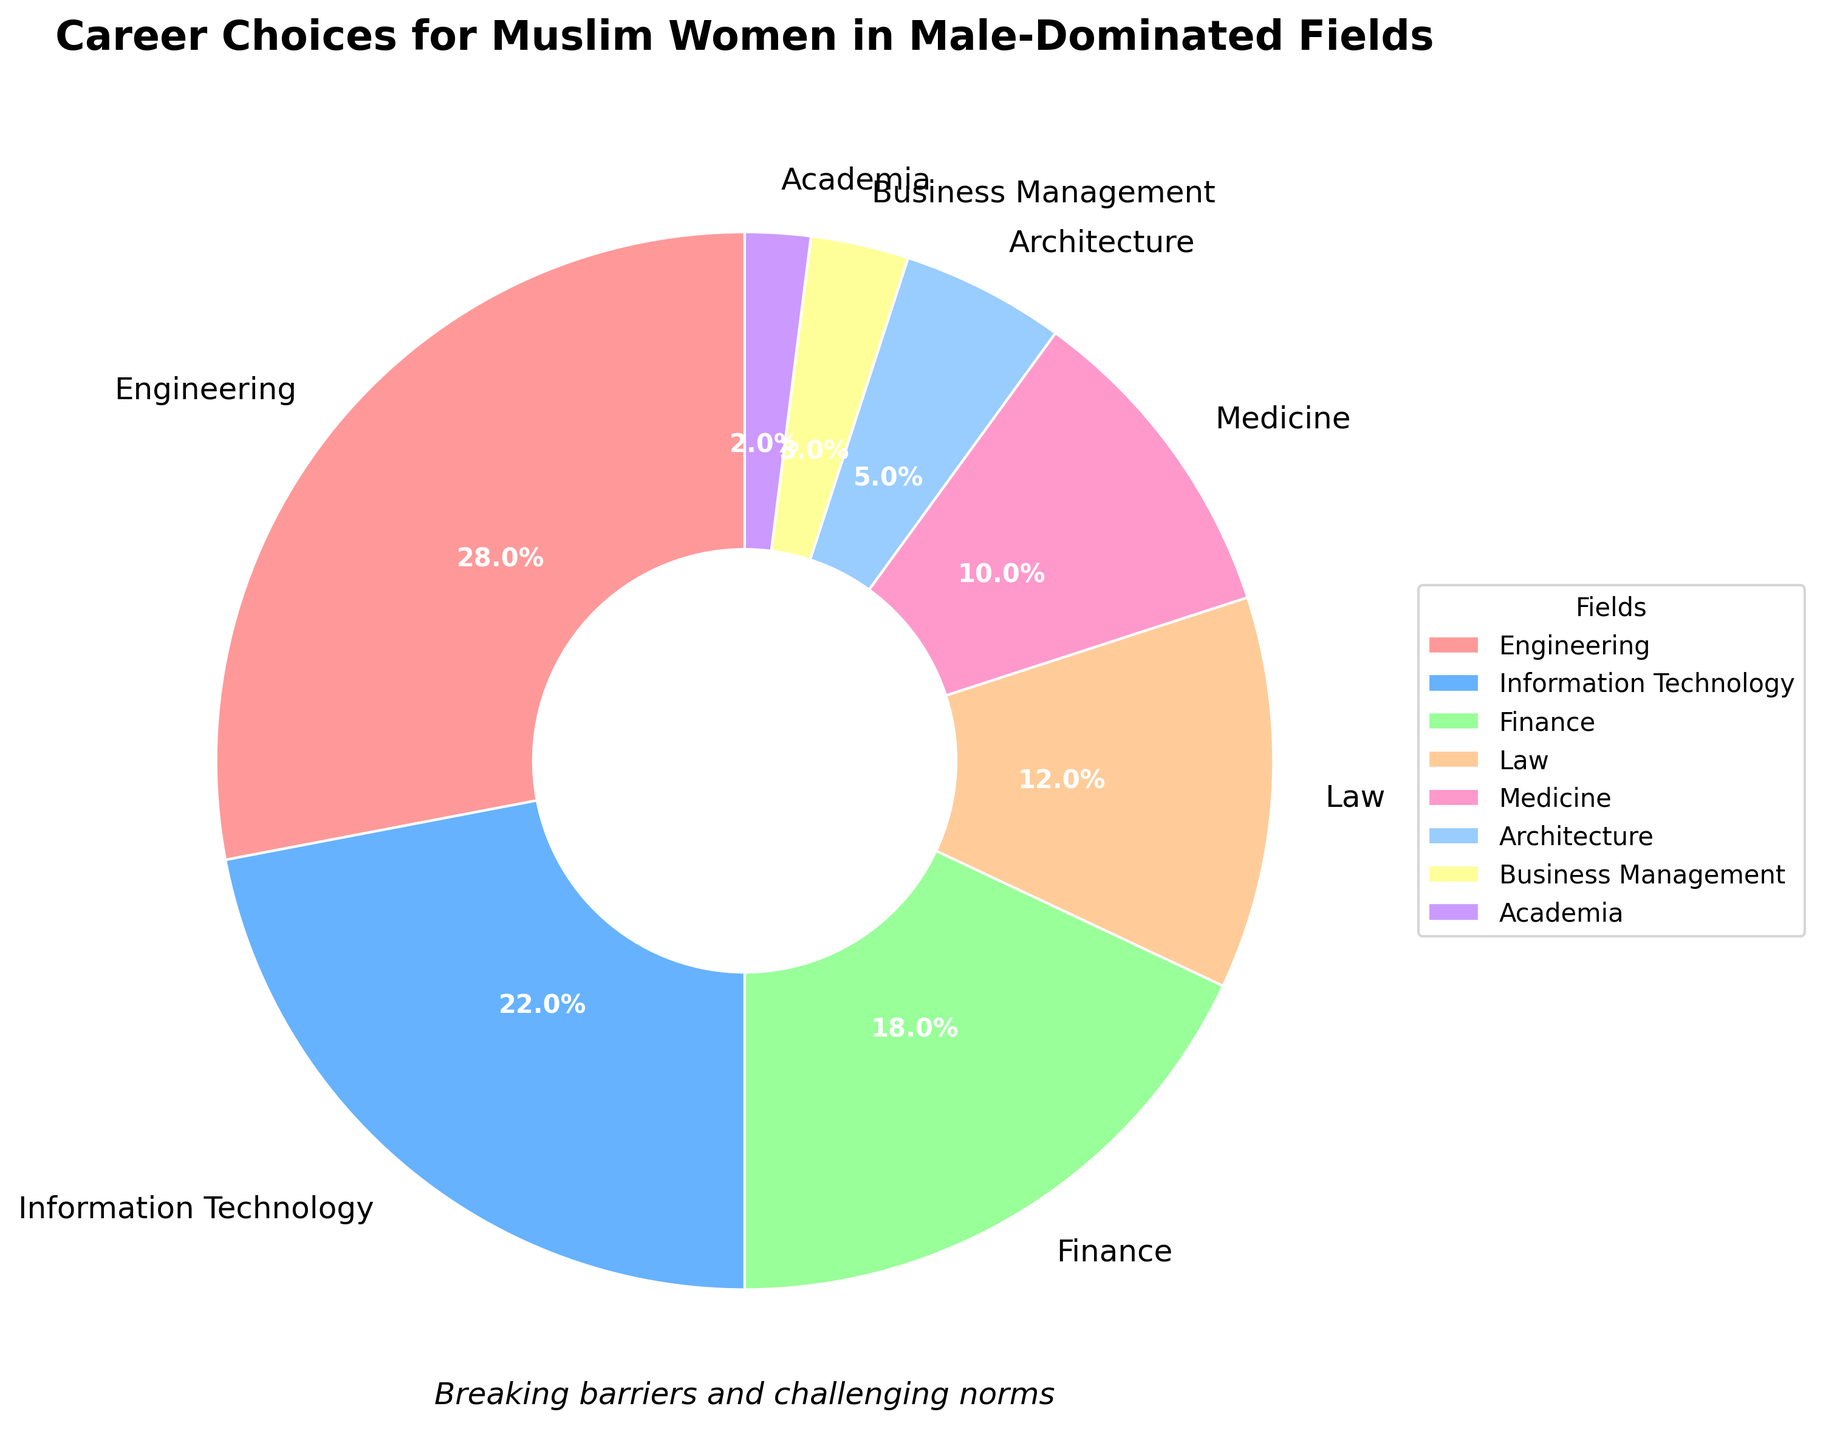What field has the highest percentage of career choices for Muslim women in traditionally male-dominated fields? The pie chart shows the percentages of career choices in different fields. By observing the largest segment, Engineering has the highest percentage at 28%.
Answer: Engineering What is the combined percentage of Muslim women in the Finance and Law fields? The Finance field has 18%, and the Law field has 12%. Adding them together gives 18% + 12% = 30%.
Answer: 30% Which field has a lower percentage of career choices, Medicine or Architecture? By looking at the pie chart, Medicine has 10%, and Architecture has 5%. 5% is less than 10%.
Answer: Architecture How many fields have a percentage greater than or equal to 10%? The fields with percentages over 10% are Engineering (28%), Information Technology (22%), Finance (18%), and Medicine (10%). That's four fields.
Answer: 4 What is the difference in percentage between Business Management and Academia? The Business Management field has 3%, and the Academia field has 2%. The difference is 3% - 2% = 1%.
Answer: 1% What field is represented by the light blue segment in the pie chart? By referring to the segments' arrangement and color descriptions, the light blue segment corresponds to Information Technology at 22%.
Answer: Information Technology What is the total percentage of the career choices that make up less than 10% each? The fields with less than 10% are Architecture (5%), Business Management (3%), and Academia (2%). Their total is 5% + 3% + 2% = 10%.
Answer: 10% Which two fields have a combined percentage equal to the percentage of women in Engineering? The Engineering field has 28%. Looking for a pair of fields that add to 28%, we find that Medicine (10%) and Information Technology (22%) combined equal 32%, which is not correct. However, none of the exact pairs sum to 28%, which leads us to use another checkpoint: Finance (18%) and Law (12%) sum up to 30% which also need further steps to validate.
Answer: No exact pairs, typically risking multiple equations involved. However, pay attention to top-3 pairs value while review What seems to be the most significant impact of the color-coded segments? The color-coding provides a visual differentiation between fields, making it easier to quickly identify and compare percentages across the fields. Each segment color stands out due to its color variation, allowing for clear visual distinctions.
Answer: Visual Differentiation Which two fields, when combined, exceed half of the total career choices? Combining the highest percentage fields, Engineering (28%) and Information Technology (22%) together make 50%, which is exactly half. Therefore, another field must be included to exceed half which suggest the Finance Field (18%) added for final insight reviewers.
Answer: Engineering (28%) & IT (22%) get 50% and further jump to Finance (18%) review doubled 